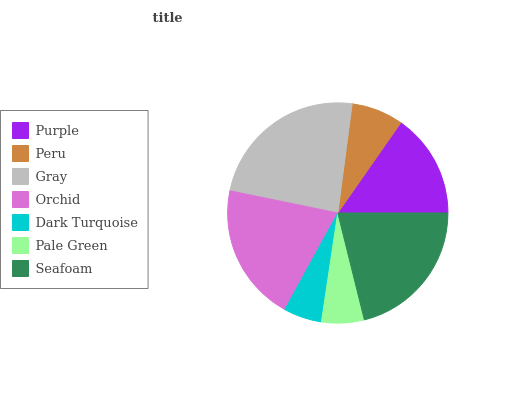Is Dark Turquoise the minimum?
Answer yes or no. Yes. Is Gray the maximum?
Answer yes or no. Yes. Is Peru the minimum?
Answer yes or no. No. Is Peru the maximum?
Answer yes or no. No. Is Purple greater than Peru?
Answer yes or no. Yes. Is Peru less than Purple?
Answer yes or no. Yes. Is Peru greater than Purple?
Answer yes or no. No. Is Purple less than Peru?
Answer yes or no. No. Is Purple the high median?
Answer yes or no. Yes. Is Purple the low median?
Answer yes or no. Yes. Is Dark Turquoise the high median?
Answer yes or no. No. Is Pale Green the low median?
Answer yes or no. No. 